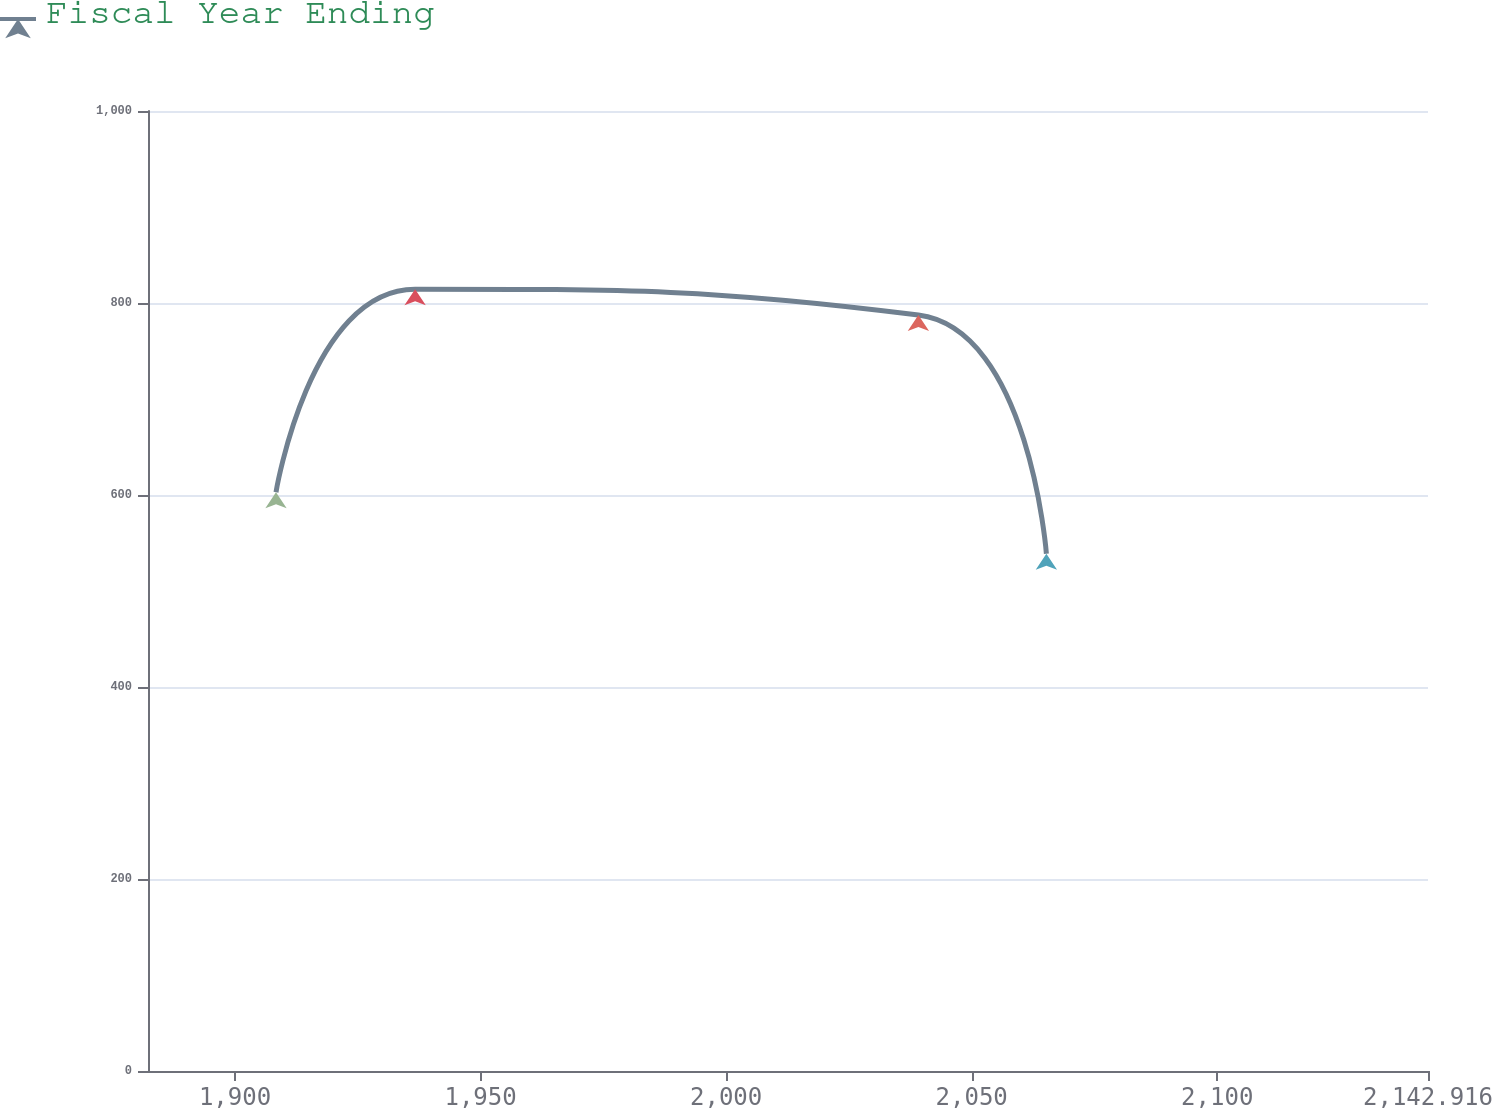Convert chart. <chart><loc_0><loc_0><loc_500><loc_500><line_chart><ecel><fcel>Fiscal Year Ending<nl><fcel>1908.34<fcel>602.89<nl><fcel>1936.67<fcel>814.36<nl><fcel>2039.15<fcel>787.49<nl><fcel>2065.21<fcel>538.81<nl><fcel>2168.98<fcel>565.68<nl></chart> 